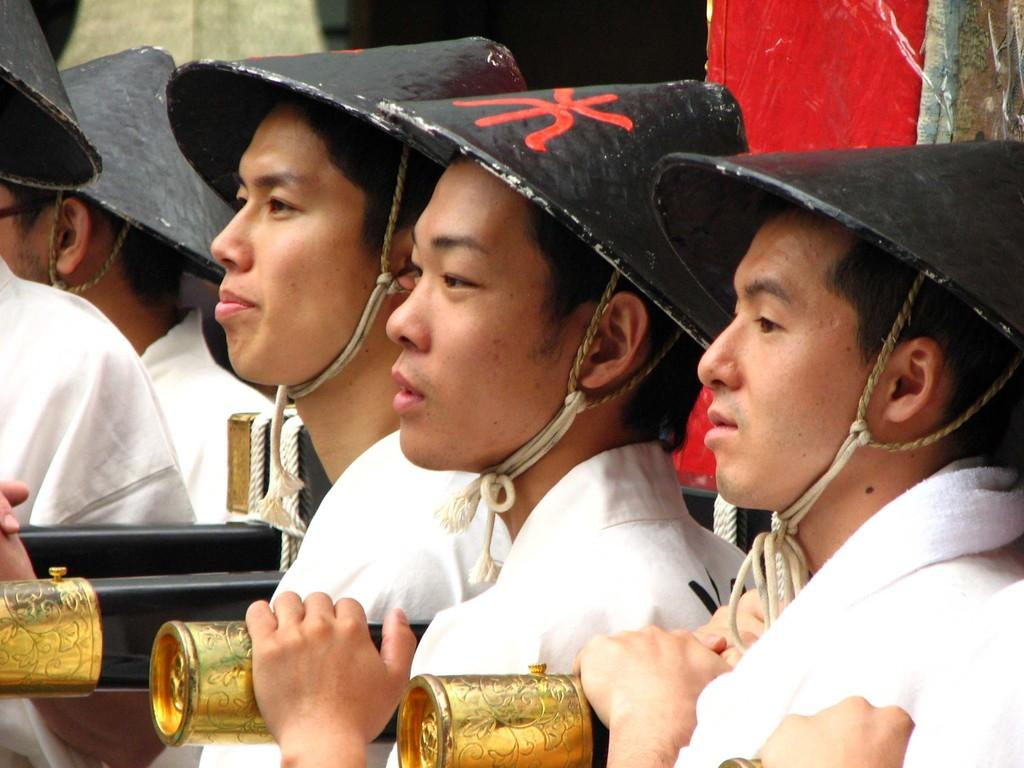What is the main subject of the image? The main subject of the image is people. How are the people positioned in the image? The people are standing in the center of the image. What can be observed about the people's clothing in the image? The people are wearing black color hats. What type of toys can be seen in the image? There are no toys present in the image. Is there any mention of payment in the image? There is no mention of payment in the image. 